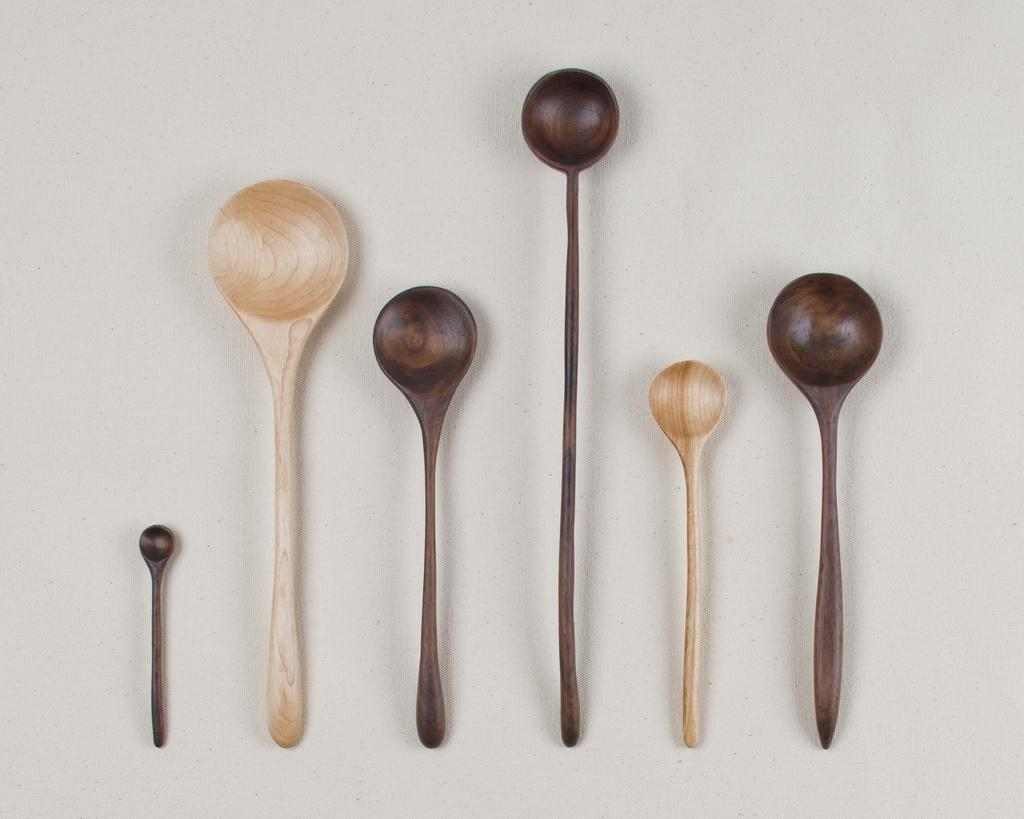What types of utensils can be seen in the image? There are different types of spoons in the image. What is the background of the image? There appears to be a wall at the bottom of the image. Reasoning: Let' Let's think step by step in order to produce the conversation. We start by identifying the main subject in the image, which is the spoons. Then, we expand the conversation to include the background of the image, which is a wall. Each question is designed to elicit a specific detail about the image that is known from the provided facts. Absurd Question/Answer: How does the sponge stop the bee from flying in the image? There is no sponge or bee present in the image. 